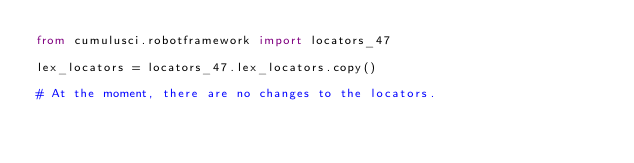<code> <loc_0><loc_0><loc_500><loc_500><_Python_>from cumulusci.robotframework import locators_47

lex_locators = locators_47.lex_locators.copy()

# At the moment, there are no changes to the locators.
</code> 